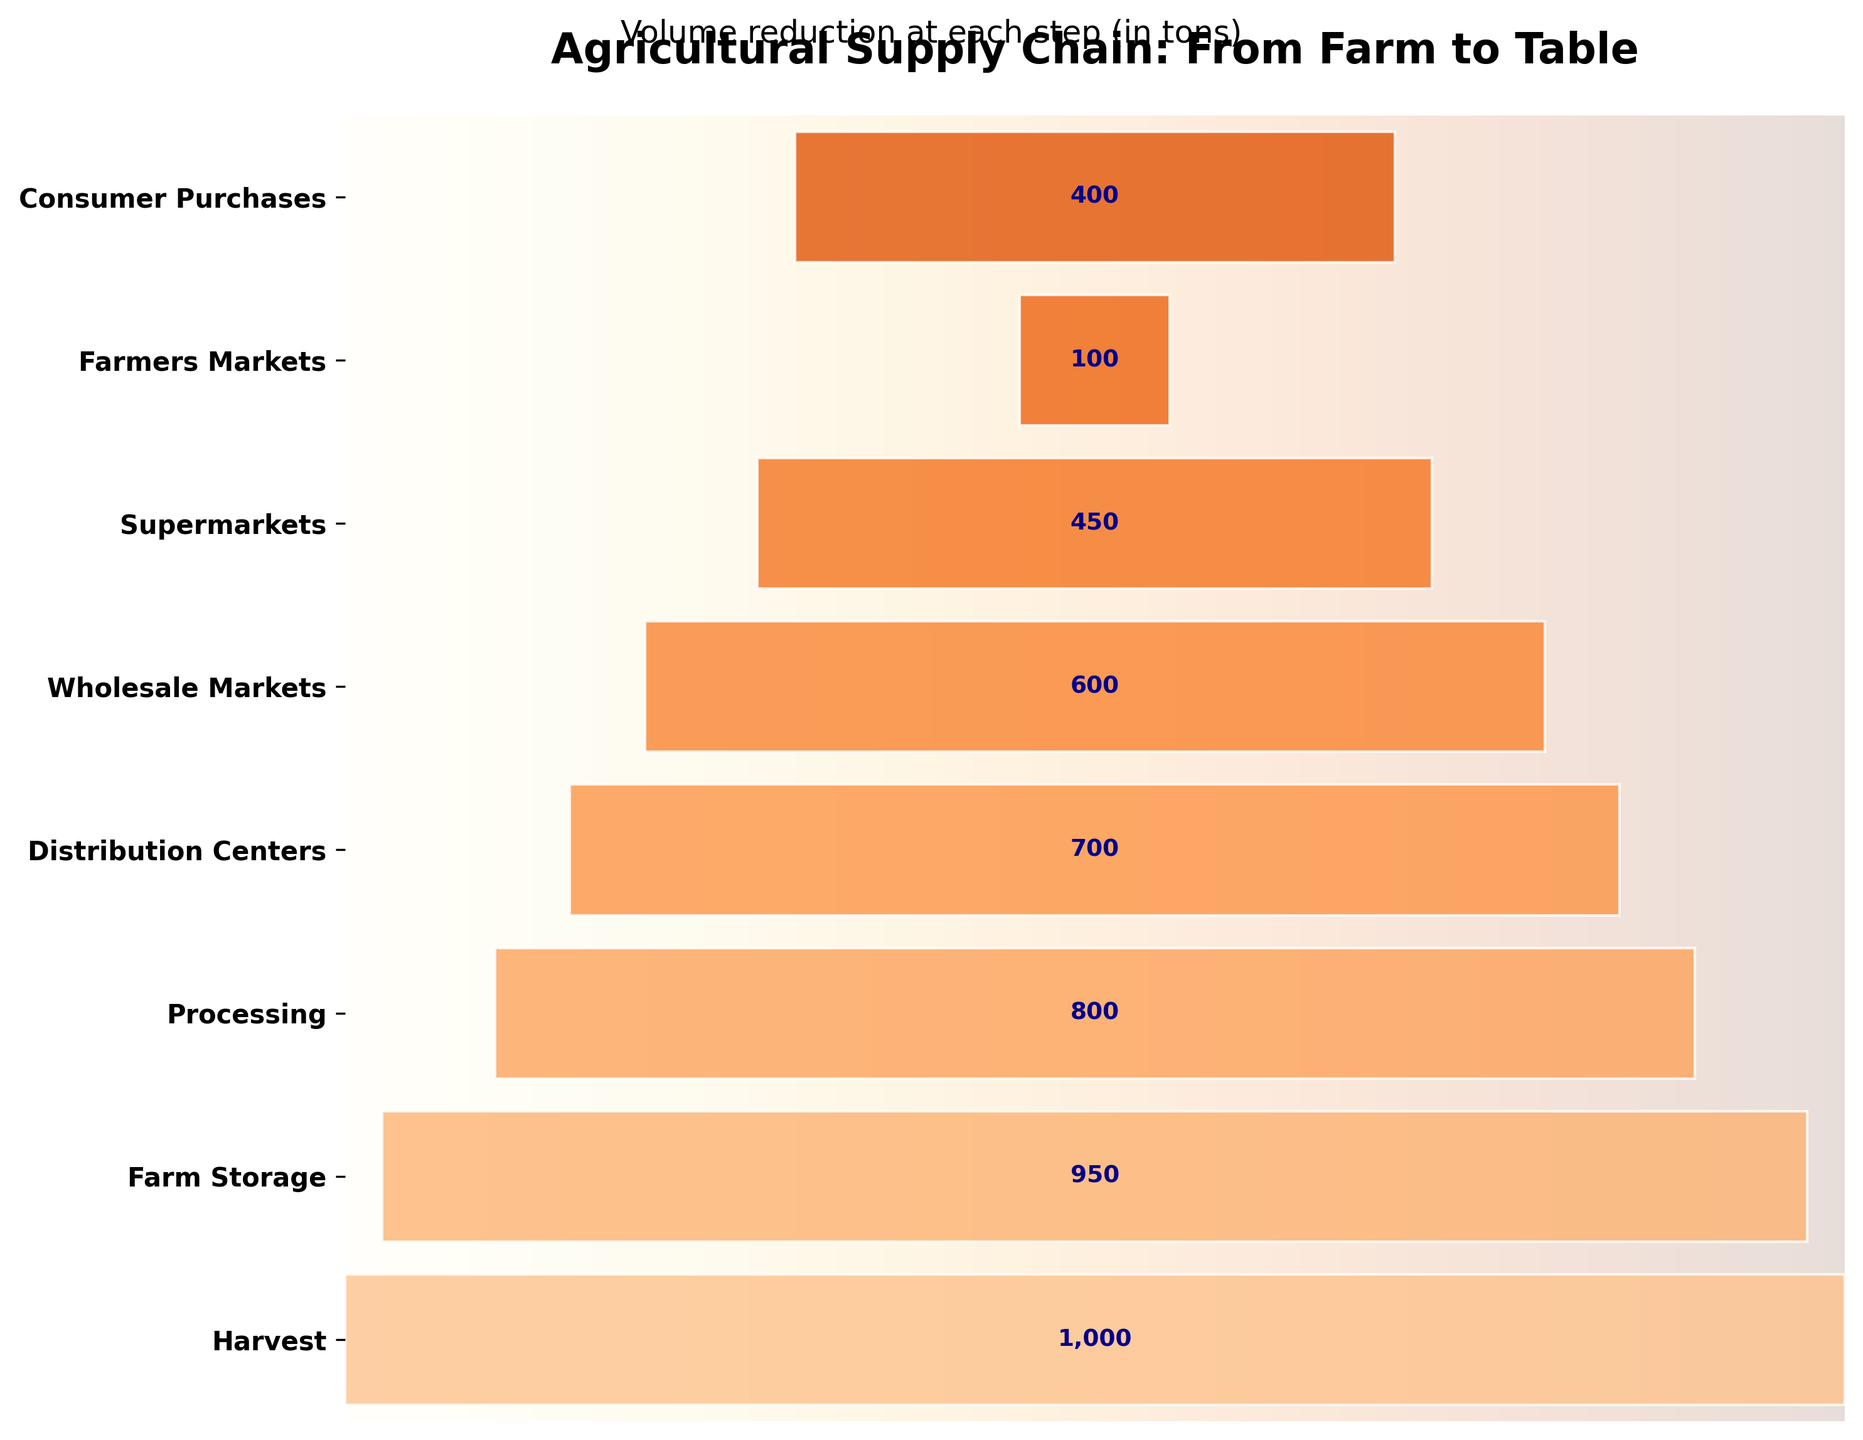What is the title of the chart? The title of the chart is located at the top and reads "Agricultural Supply Chain: From Farm to Table".
Answer: Agricultural Supply Chain: From Farm to Table How many steps are displayed in the funnel chart? You can count the labeled horizontal bars which represent each step to determine there are eight steps in the chart.
Answer: Eight Which step has the highest volume and what is it? By looking from top to bottom, the largest bar near the top corresponds to the Harvest step with a volume of 1000 tons.
Answer: Harvest, 1000 tons What is the final step shown in the funnel chart? The last horizontal bar at the bottom of the chart corresponds to Consumer Purchases.
Answer: Consumer Purchases How much volume is lost between the Harvest and Supermarkets stages? From the Harvest to Supermarkets, the volumes are 1000 and 450 tons respectively. The loss is calculated as 1000 - 450 = 550 tons.
Answer: 550 tons Which stage sees the largest reduction in volume? By comparing the differences in volume between each successive stage, the largest drop is between Wholesale Markets (600) and Supermarkets (450), which is 600 - 450 = 150 tons.
Answer: Wholesale Markets to Supermarkets What is the decrease in volume from Distribution Centers to Wholesale Markets? The volume at Distribution Centers is 700 tons, while at Wholesale Markets it is 600 tons. The decrease is 700 - 600 = 100 tons.
Answer: 100 tons How does the volume compare between Farmers Markets and Supermarkets? Farmers Markets have a volume of 100 tons, whereas Supermarkets have a volume of 450 tons. Farmers Markets have less volume compared to Supermarkets by 450 - 100 = 350 tons.
Answer: Farmers Markets have 350 tons less What is the total volume from Processing to Consumer Purchases? Sum the volumes from the Processing (800), Distribution Centers (700), Wholesale Markets (600), Supermarkets (450), Farmers Markets (100), to Consumer Purchases (400). So, the total volume is 800 + 700 + 600 + 450 + 100 + 400 = 3050 tons.
Answer: 3050 tons What percentage of the initial volume (Harvest) reaches the Supermarkets? The initial volume at Harvest is 1000 tons, and the volume at Supermarkets is 450 tons. The percentage is (450 / 1000) * 100 = 45%.
Answer: 45% 